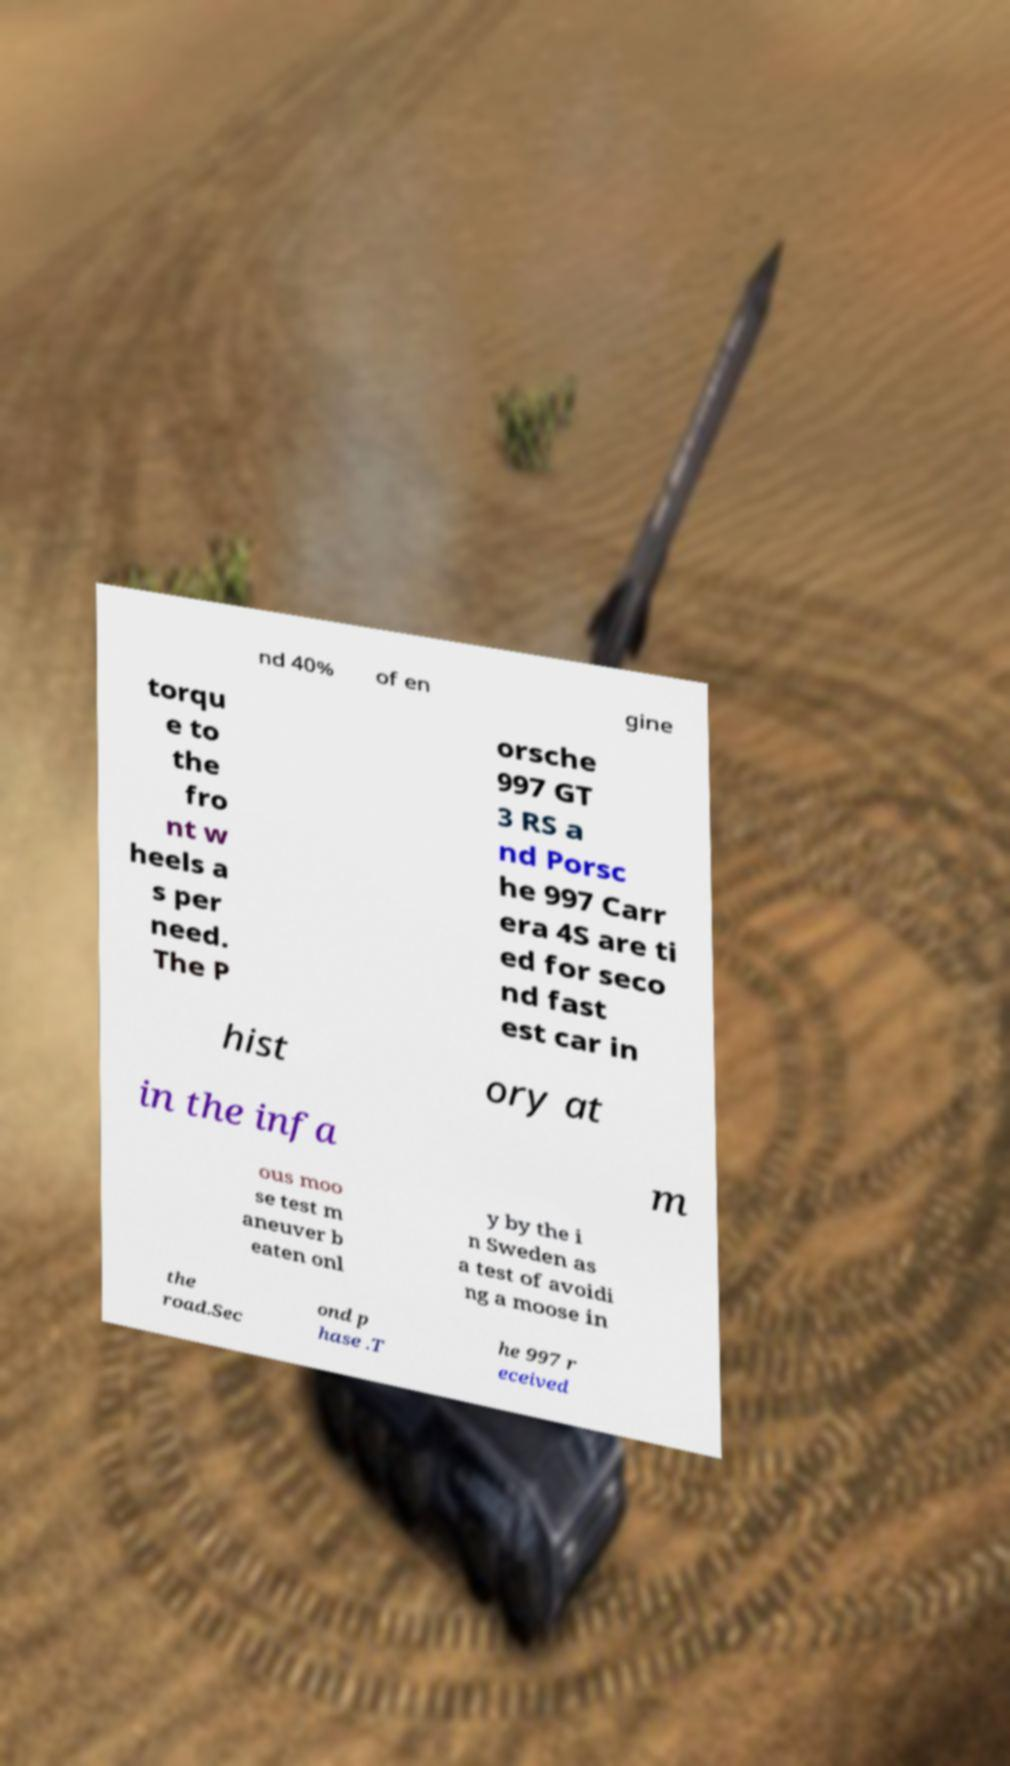What messages or text are displayed in this image? I need them in a readable, typed format. nd 40% of en gine torqu e to the fro nt w heels a s per need. The P orsche 997 GT 3 RS a nd Porsc he 997 Carr era 4S are ti ed for seco nd fast est car in hist ory at in the infa m ous moo se test m aneuver b eaten onl y by the i n Sweden as a test of avoidi ng a moose in the road.Sec ond p hase .T he 997 r eceived 